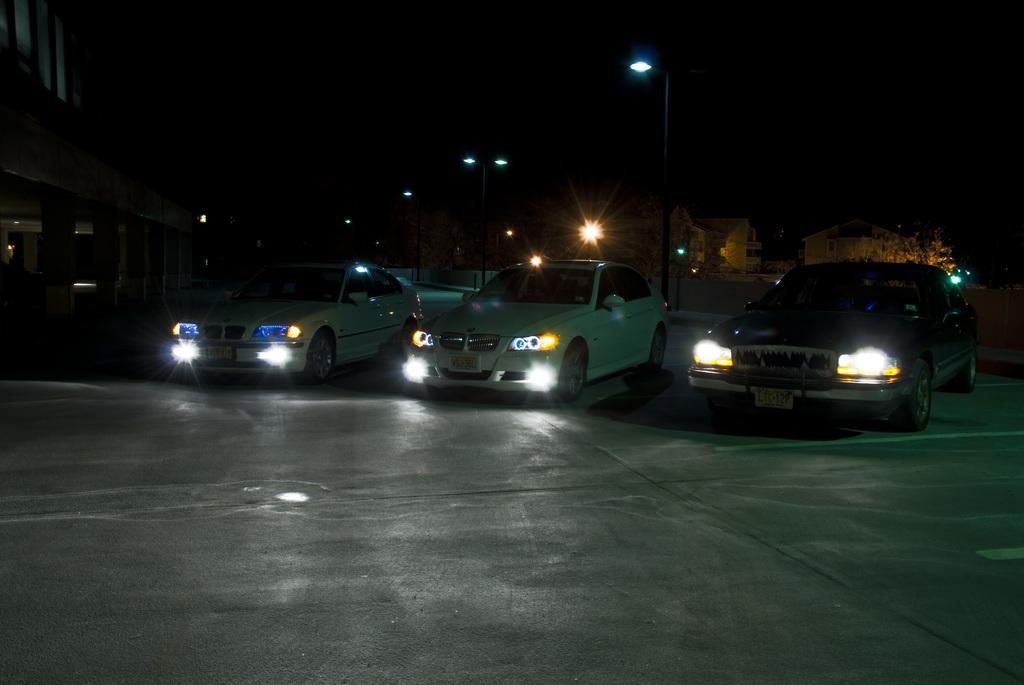What type of vehicles can be seen on the road in the image? There are cars on the road in the image. What is located in the background of the image? There is a pole, lights, trees, and buildings in the background of the image. How many snakes are slithering on the pole in the image? There are no snakes present in the image; the pole is in the background without any snakes. 